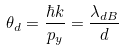Convert formula to latex. <formula><loc_0><loc_0><loc_500><loc_500>\theta _ { d } = \frac { \hbar { k } } { p _ { y } } = \frac { \lambda _ { d B } } d</formula> 